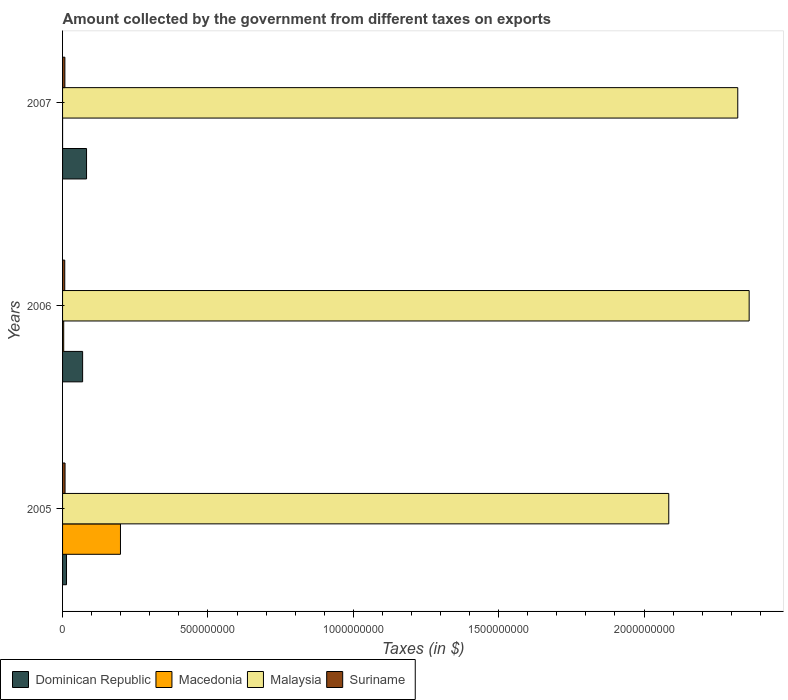How many groups of bars are there?
Your answer should be compact. 3. How many bars are there on the 1st tick from the bottom?
Give a very brief answer. 4. In how many cases, is the number of bars for a given year not equal to the number of legend labels?
Give a very brief answer. 0. What is the amount collected by the government from taxes on exports in Dominican Republic in 2006?
Your answer should be compact. 6.90e+07. Across all years, what is the maximum amount collected by the government from taxes on exports in Malaysia?
Make the answer very short. 2.36e+09. Across all years, what is the minimum amount collected by the government from taxes on exports in Dominican Republic?
Provide a short and direct response. 1.36e+07. In which year was the amount collected by the government from taxes on exports in Macedonia minimum?
Provide a succinct answer. 2007. What is the total amount collected by the government from taxes on exports in Malaysia in the graph?
Ensure brevity in your answer.  6.77e+09. What is the difference between the amount collected by the government from taxes on exports in Suriname in 2006 and that in 2007?
Your answer should be very brief. -4.53e+05. What is the difference between the amount collected by the government from taxes on exports in Macedonia in 2005 and the amount collected by the government from taxes on exports in Dominican Republic in 2007?
Your answer should be compact. 1.17e+08. What is the average amount collected by the government from taxes on exports in Malaysia per year?
Make the answer very short. 2.26e+09. In the year 2006, what is the difference between the amount collected by the government from taxes on exports in Suriname and amount collected by the government from taxes on exports in Malaysia?
Ensure brevity in your answer.  -2.35e+09. In how many years, is the amount collected by the government from taxes on exports in Dominican Republic greater than 2200000000 $?
Offer a terse response. 0. What is the ratio of the amount collected by the government from taxes on exports in Macedonia in 2006 to that in 2007?
Offer a terse response. 297.99. Is the amount collected by the government from taxes on exports in Malaysia in 2006 less than that in 2007?
Your answer should be very brief. No. Is the difference between the amount collected by the government from taxes on exports in Suriname in 2005 and 2006 greater than the difference between the amount collected by the government from taxes on exports in Malaysia in 2005 and 2006?
Your answer should be compact. Yes. What is the difference between the highest and the second highest amount collected by the government from taxes on exports in Malaysia?
Offer a very short reply. 3.92e+07. What is the difference between the highest and the lowest amount collected by the government from taxes on exports in Suriname?
Ensure brevity in your answer.  1.03e+06. Is it the case that in every year, the sum of the amount collected by the government from taxes on exports in Dominican Republic and amount collected by the government from taxes on exports in Macedonia is greater than the sum of amount collected by the government from taxes on exports in Suriname and amount collected by the government from taxes on exports in Malaysia?
Offer a terse response. No. What does the 4th bar from the top in 2007 represents?
Offer a very short reply. Dominican Republic. What does the 2nd bar from the bottom in 2005 represents?
Your answer should be compact. Macedonia. Is it the case that in every year, the sum of the amount collected by the government from taxes on exports in Suriname and amount collected by the government from taxes on exports in Dominican Republic is greater than the amount collected by the government from taxes on exports in Macedonia?
Your response must be concise. No. How many bars are there?
Keep it short and to the point. 12. How many years are there in the graph?
Make the answer very short. 3. Does the graph contain grids?
Provide a succinct answer. No. How many legend labels are there?
Your answer should be compact. 4. What is the title of the graph?
Offer a terse response. Amount collected by the government from different taxes on exports. What is the label or title of the X-axis?
Provide a succinct answer. Taxes (in $). What is the label or title of the Y-axis?
Your response must be concise. Years. What is the Taxes (in $) in Dominican Republic in 2005?
Your response must be concise. 1.36e+07. What is the Taxes (in $) of Macedonia in 2005?
Keep it short and to the point. 1.99e+08. What is the Taxes (in $) in Malaysia in 2005?
Give a very brief answer. 2.08e+09. What is the Taxes (in $) in Suriname in 2005?
Provide a short and direct response. 8.52e+06. What is the Taxes (in $) of Dominican Republic in 2006?
Your response must be concise. 6.90e+07. What is the Taxes (in $) of Macedonia in 2006?
Ensure brevity in your answer.  3.90e+06. What is the Taxes (in $) of Malaysia in 2006?
Your answer should be compact. 2.36e+09. What is the Taxes (in $) of Suriname in 2006?
Keep it short and to the point. 7.49e+06. What is the Taxes (in $) in Dominican Republic in 2007?
Offer a terse response. 8.25e+07. What is the Taxes (in $) of Macedonia in 2007?
Offer a terse response. 1.31e+04. What is the Taxes (in $) in Malaysia in 2007?
Your answer should be very brief. 2.32e+09. What is the Taxes (in $) in Suriname in 2007?
Give a very brief answer. 7.95e+06. Across all years, what is the maximum Taxes (in $) of Dominican Republic?
Your answer should be very brief. 8.25e+07. Across all years, what is the maximum Taxes (in $) in Macedonia?
Provide a succinct answer. 1.99e+08. Across all years, what is the maximum Taxes (in $) of Malaysia?
Provide a short and direct response. 2.36e+09. Across all years, what is the maximum Taxes (in $) in Suriname?
Offer a terse response. 8.52e+06. Across all years, what is the minimum Taxes (in $) in Dominican Republic?
Make the answer very short. 1.36e+07. Across all years, what is the minimum Taxes (in $) in Macedonia?
Your answer should be very brief. 1.31e+04. Across all years, what is the minimum Taxes (in $) of Malaysia?
Provide a succinct answer. 2.08e+09. Across all years, what is the minimum Taxes (in $) of Suriname?
Your answer should be very brief. 7.49e+06. What is the total Taxes (in $) in Dominican Republic in the graph?
Ensure brevity in your answer.  1.65e+08. What is the total Taxes (in $) of Macedonia in the graph?
Keep it short and to the point. 2.03e+08. What is the total Taxes (in $) of Malaysia in the graph?
Provide a succinct answer. 6.77e+09. What is the total Taxes (in $) of Suriname in the graph?
Ensure brevity in your answer.  2.40e+07. What is the difference between the Taxes (in $) of Dominican Republic in 2005 and that in 2006?
Keep it short and to the point. -5.54e+07. What is the difference between the Taxes (in $) in Macedonia in 2005 and that in 2006?
Make the answer very short. 1.95e+08. What is the difference between the Taxes (in $) of Malaysia in 2005 and that in 2006?
Ensure brevity in your answer.  -2.77e+08. What is the difference between the Taxes (in $) in Suriname in 2005 and that in 2006?
Offer a terse response. 1.03e+06. What is the difference between the Taxes (in $) of Dominican Republic in 2005 and that in 2007?
Your answer should be very brief. -6.89e+07. What is the difference between the Taxes (in $) in Macedonia in 2005 and that in 2007?
Offer a terse response. 1.99e+08. What is the difference between the Taxes (in $) in Malaysia in 2005 and that in 2007?
Your answer should be compact. -2.37e+08. What is the difference between the Taxes (in $) in Suriname in 2005 and that in 2007?
Give a very brief answer. 5.72e+05. What is the difference between the Taxes (in $) in Dominican Republic in 2006 and that in 2007?
Your answer should be very brief. -1.35e+07. What is the difference between the Taxes (in $) in Macedonia in 2006 and that in 2007?
Your response must be concise. 3.88e+06. What is the difference between the Taxes (in $) in Malaysia in 2006 and that in 2007?
Offer a terse response. 3.92e+07. What is the difference between the Taxes (in $) of Suriname in 2006 and that in 2007?
Your answer should be very brief. -4.53e+05. What is the difference between the Taxes (in $) in Dominican Republic in 2005 and the Taxes (in $) in Macedonia in 2006?
Provide a short and direct response. 9.67e+06. What is the difference between the Taxes (in $) in Dominican Republic in 2005 and the Taxes (in $) in Malaysia in 2006?
Your answer should be compact. -2.35e+09. What is the difference between the Taxes (in $) of Dominican Republic in 2005 and the Taxes (in $) of Suriname in 2006?
Provide a succinct answer. 6.07e+06. What is the difference between the Taxes (in $) of Macedonia in 2005 and the Taxes (in $) of Malaysia in 2006?
Make the answer very short. -2.16e+09. What is the difference between the Taxes (in $) of Macedonia in 2005 and the Taxes (in $) of Suriname in 2006?
Offer a very short reply. 1.92e+08. What is the difference between the Taxes (in $) in Malaysia in 2005 and the Taxes (in $) in Suriname in 2006?
Offer a terse response. 2.08e+09. What is the difference between the Taxes (in $) in Dominican Republic in 2005 and the Taxes (in $) in Macedonia in 2007?
Give a very brief answer. 1.36e+07. What is the difference between the Taxes (in $) in Dominican Republic in 2005 and the Taxes (in $) in Malaysia in 2007?
Your answer should be very brief. -2.31e+09. What is the difference between the Taxes (in $) in Dominican Republic in 2005 and the Taxes (in $) in Suriname in 2007?
Give a very brief answer. 5.62e+06. What is the difference between the Taxes (in $) of Macedonia in 2005 and the Taxes (in $) of Malaysia in 2007?
Your answer should be very brief. -2.12e+09. What is the difference between the Taxes (in $) in Macedonia in 2005 and the Taxes (in $) in Suriname in 2007?
Your answer should be compact. 1.91e+08. What is the difference between the Taxes (in $) of Malaysia in 2005 and the Taxes (in $) of Suriname in 2007?
Provide a short and direct response. 2.08e+09. What is the difference between the Taxes (in $) of Dominican Republic in 2006 and the Taxes (in $) of Macedonia in 2007?
Your response must be concise. 6.90e+07. What is the difference between the Taxes (in $) of Dominican Republic in 2006 and the Taxes (in $) of Malaysia in 2007?
Give a very brief answer. -2.25e+09. What is the difference between the Taxes (in $) in Dominican Republic in 2006 and the Taxes (in $) in Suriname in 2007?
Offer a terse response. 6.10e+07. What is the difference between the Taxes (in $) of Macedonia in 2006 and the Taxes (in $) of Malaysia in 2007?
Offer a very short reply. -2.32e+09. What is the difference between the Taxes (in $) in Macedonia in 2006 and the Taxes (in $) in Suriname in 2007?
Make the answer very short. -4.05e+06. What is the difference between the Taxes (in $) in Malaysia in 2006 and the Taxes (in $) in Suriname in 2007?
Provide a short and direct response. 2.35e+09. What is the average Taxes (in $) of Dominican Republic per year?
Offer a very short reply. 5.50e+07. What is the average Taxes (in $) in Macedonia per year?
Offer a terse response. 6.77e+07. What is the average Taxes (in $) in Malaysia per year?
Keep it short and to the point. 2.26e+09. What is the average Taxes (in $) in Suriname per year?
Your response must be concise. 7.99e+06. In the year 2005, what is the difference between the Taxes (in $) in Dominican Republic and Taxes (in $) in Macedonia?
Give a very brief answer. -1.86e+08. In the year 2005, what is the difference between the Taxes (in $) of Dominican Republic and Taxes (in $) of Malaysia?
Your answer should be compact. -2.07e+09. In the year 2005, what is the difference between the Taxes (in $) of Dominican Republic and Taxes (in $) of Suriname?
Offer a very short reply. 5.05e+06. In the year 2005, what is the difference between the Taxes (in $) of Macedonia and Taxes (in $) of Malaysia?
Give a very brief answer. -1.89e+09. In the year 2005, what is the difference between the Taxes (in $) of Macedonia and Taxes (in $) of Suriname?
Offer a terse response. 1.91e+08. In the year 2005, what is the difference between the Taxes (in $) of Malaysia and Taxes (in $) of Suriname?
Make the answer very short. 2.08e+09. In the year 2006, what is the difference between the Taxes (in $) of Dominican Republic and Taxes (in $) of Macedonia?
Your answer should be very brief. 6.51e+07. In the year 2006, what is the difference between the Taxes (in $) in Dominican Republic and Taxes (in $) in Malaysia?
Your answer should be very brief. -2.29e+09. In the year 2006, what is the difference between the Taxes (in $) in Dominican Republic and Taxes (in $) in Suriname?
Your answer should be very brief. 6.15e+07. In the year 2006, what is the difference between the Taxes (in $) in Macedonia and Taxes (in $) in Malaysia?
Provide a succinct answer. -2.36e+09. In the year 2006, what is the difference between the Taxes (in $) in Macedonia and Taxes (in $) in Suriname?
Offer a very short reply. -3.60e+06. In the year 2006, what is the difference between the Taxes (in $) of Malaysia and Taxes (in $) of Suriname?
Your answer should be compact. 2.35e+09. In the year 2007, what is the difference between the Taxes (in $) in Dominican Republic and Taxes (in $) in Macedonia?
Your answer should be compact. 8.25e+07. In the year 2007, what is the difference between the Taxes (in $) in Dominican Republic and Taxes (in $) in Malaysia?
Your answer should be compact. -2.24e+09. In the year 2007, what is the difference between the Taxes (in $) of Dominican Republic and Taxes (in $) of Suriname?
Give a very brief answer. 7.46e+07. In the year 2007, what is the difference between the Taxes (in $) in Macedonia and Taxes (in $) in Malaysia?
Your response must be concise. -2.32e+09. In the year 2007, what is the difference between the Taxes (in $) of Macedonia and Taxes (in $) of Suriname?
Provide a short and direct response. -7.93e+06. In the year 2007, what is the difference between the Taxes (in $) in Malaysia and Taxes (in $) in Suriname?
Provide a succinct answer. 2.31e+09. What is the ratio of the Taxes (in $) in Dominican Republic in 2005 to that in 2006?
Provide a succinct answer. 0.2. What is the ratio of the Taxes (in $) of Macedonia in 2005 to that in 2006?
Make the answer very short. 51.11. What is the ratio of the Taxes (in $) in Malaysia in 2005 to that in 2006?
Offer a terse response. 0.88. What is the ratio of the Taxes (in $) in Suriname in 2005 to that in 2006?
Your answer should be very brief. 1.14. What is the ratio of the Taxes (in $) in Dominican Republic in 2005 to that in 2007?
Keep it short and to the point. 0.16. What is the ratio of the Taxes (in $) in Macedonia in 2005 to that in 2007?
Make the answer very short. 1.52e+04. What is the ratio of the Taxes (in $) of Malaysia in 2005 to that in 2007?
Make the answer very short. 0.9. What is the ratio of the Taxes (in $) in Suriname in 2005 to that in 2007?
Ensure brevity in your answer.  1.07. What is the ratio of the Taxes (in $) of Dominican Republic in 2006 to that in 2007?
Ensure brevity in your answer.  0.84. What is the ratio of the Taxes (in $) of Macedonia in 2006 to that in 2007?
Keep it short and to the point. 297.99. What is the ratio of the Taxes (in $) in Malaysia in 2006 to that in 2007?
Offer a very short reply. 1.02. What is the ratio of the Taxes (in $) of Suriname in 2006 to that in 2007?
Offer a very short reply. 0.94. What is the difference between the highest and the second highest Taxes (in $) in Dominican Republic?
Offer a very short reply. 1.35e+07. What is the difference between the highest and the second highest Taxes (in $) in Macedonia?
Your answer should be very brief. 1.95e+08. What is the difference between the highest and the second highest Taxes (in $) of Malaysia?
Make the answer very short. 3.92e+07. What is the difference between the highest and the second highest Taxes (in $) in Suriname?
Your answer should be compact. 5.72e+05. What is the difference between the highest and the lowest Taxes (in $) in Dominican Republic?
Offer a very short reply. 6.89e+07. What is the difference between the highest and the lowest Taxes (in $) of Macedonia?
Ensure brevity in your answer.  1.99e+08. What is the difference between the highest and the lowest Taxes (in $) in Malaysia?
Keep it short and to the point. 2.77e+08. What is the difference between the highest and the lowest Taxes (in $) in Suriname?
Keep it short and to the point. 1.03e+06. 